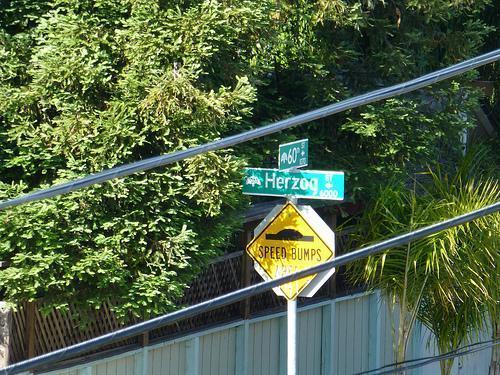How many poles are there?
Give a very brief answer. 1. 